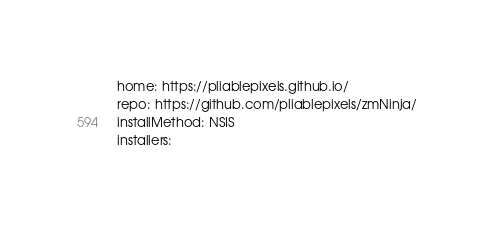Convert code to text. <code><loc_0><loc_0><loc_500><loc_500><_YAML_>home: https://pliablepixels.github.io/
repo: https://github.com/pliablepixels/zmNinja/
installMethod: NSIS
installers:</code> 